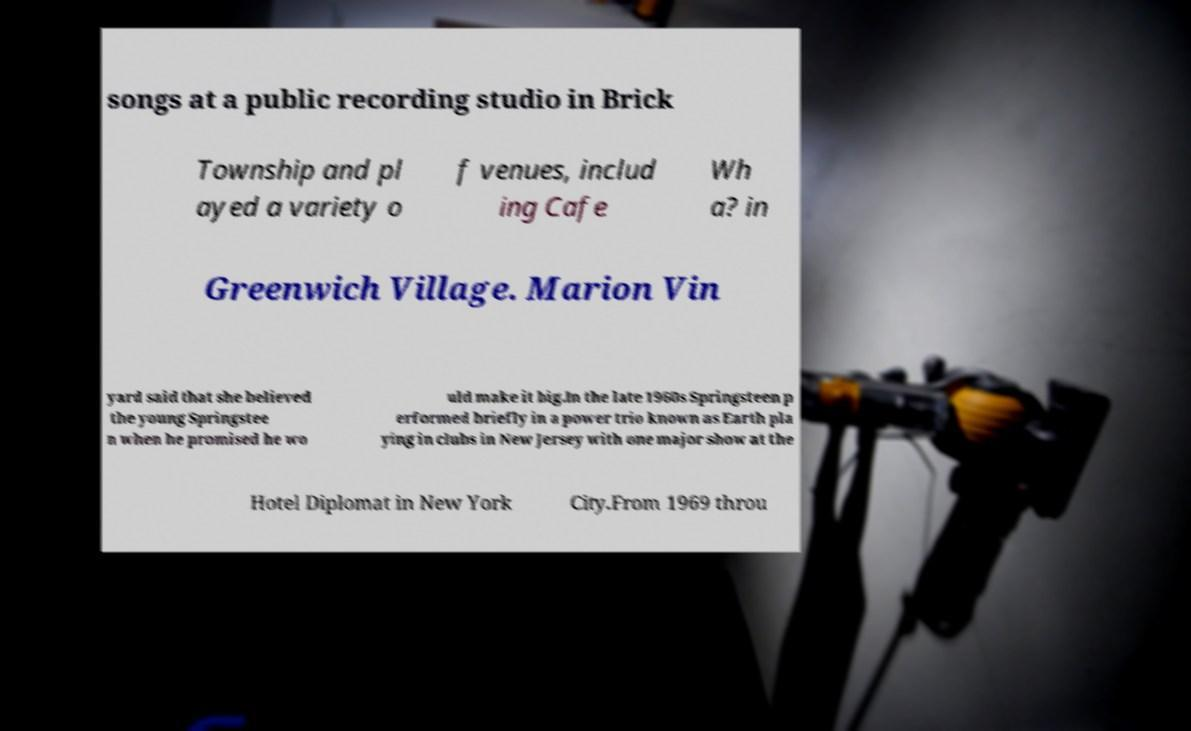Please read and relay the text visible in this image. What does it say? songs at a public recording studio in Brick Township and pl ayed a variety o f venues, includ ing Cafe Wh a? in Greenwich Village. Marion Vin yard said that she believed the young Springstee n when he promised he wo uld make it big.In the late 1960s Springsteen p erformed briefly in a power trio known as Earth pla ying in clubs in New Jersey with one major show at the Hotel Diplomat in New York City.From 1969 throu 